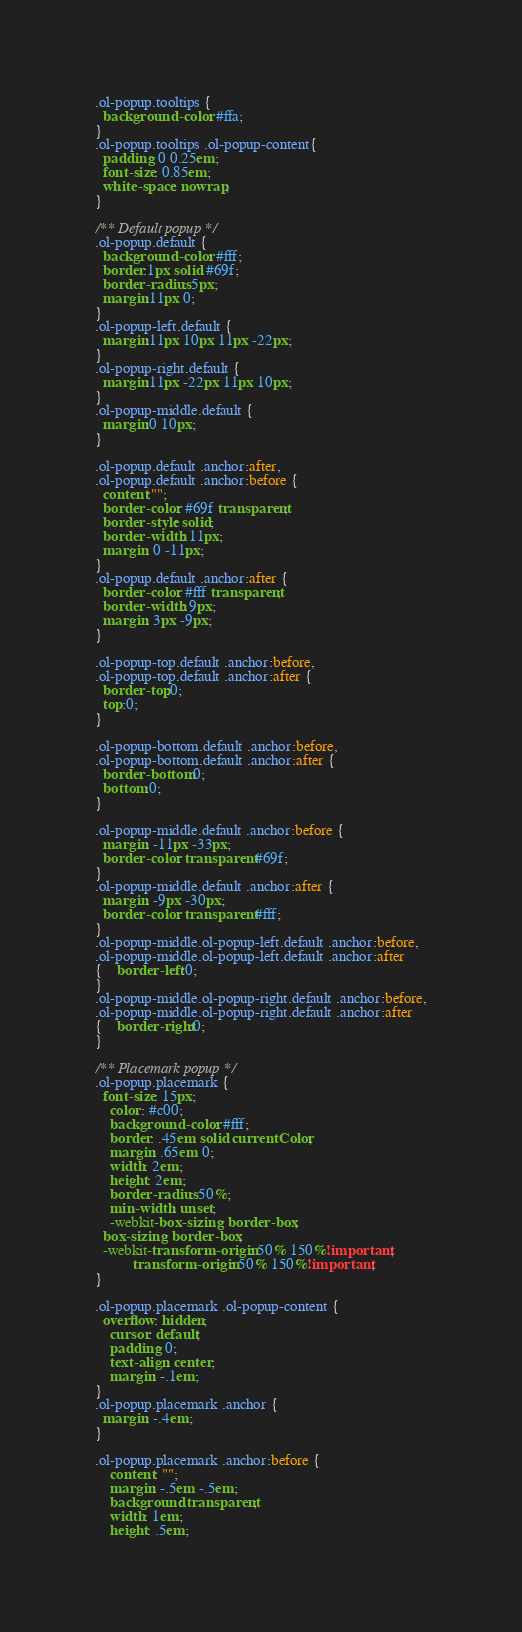<code> <loc_0><loc_0><loc_500><loc_500><_CSS_>.ol-popup.tooltips {
  background-color: #ffa;
}
.ol-popup.tooltips .ol-popup-content{
  padding: 0 0.25em;
  font-size: 0.85em;
  white-space: nowrap;
}

/** Default popup */
.ol-popup.default {
  background-color: #fff;
  border:1px solid #69f;
  border-radius: 5px;
  margin:11px 0;
}
.ol-popup-left.default {
  margin:11px 10px 11px -22px;
}
.ol-popup-right.default {
  margin:11px -22px 11px 10px;
}
.ol-popup-middle.default {
  margin:0 10px;
}

.ol-popup.default .anchor:after,
.ol-popup.default .anchor:before {
  content:"";
  border-color: #69f transparent;
  border-style: solid;
  border-width: 11px;
  margin: 0 -11px;
}
.ol-popup.default .anchor:after {
  border-color: #fff transparent;
  border-width: 9px;
  margin: 3px -9px;
}

.ol-popup-top.default .anchor:before,
.ol-popup-top.default .anchor:after {
  border-top:0;
  top:0;
}

.ol-popup-bottom.default .anchor:before,
.ol-popup-bottom.default .anchor:after {
  border-bottom:0;
  bottom:0;
}

.ol-popup-middle.default .anchor:before {
  margin: -11px -33px;
  border-color: transparent #69f;
}
.ol-popup-middle.default .anchor:after {
  margin: -9px -30px;
  border-color: transparent #fff;
}
.ol-popup-middle.ol-popup-left.default .anchor:before,
.ol-popup-middle.ol-popup-left.default .anchor:after
{	border-left:0;
}
.ol-popup-middle.ol-popup-right.default .anchor:before,
.ol-popup-middle.ol-popup-right.default .anchor:after
{	border-right:0;
}

/** Placemark popup */
.ol-popup.placemark {
  font-size: 15px;	
    color: #c00;
    background-color: #fff;
    border: .45em solid currentColor;
    margin: .65em 0;
    width: 2em;
    height: 2em;
    border-radius: 50%;
    min-width: unset;
    -webkit-box-sizing: border-box;
  box-sizing: border-box;
  -webkit-transform-origin: 50% 150%!important;
          transform-origin: 50% 150%!important;
}

.ol-popup.placemark .ol-popup-content {
  overflow: hidden;
    cursor: default;
    padding: 0;
    text-align: center;
    margin: -.1em;
}
.ol-popup.placemark .anchor {
  margin: -.4em;
}

.ol-popup.placemark .anchor:before {
    content: "";
    margin: -.5em -.5em;
    background: transparent;
    width: 1em;
    height: .5em;</code> 